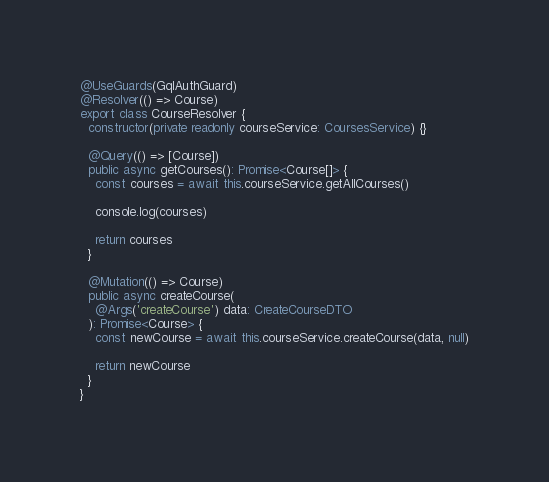Convert code to text. <code><loc_0><loc_0><loc_500><loc_500><_TypeScript_>@UseGuards(GqlAuthGuard)
@Resolver(() => Course)
export class CourseResolver {
  constructor(private readonly courseService: CoursesService) {}

  @Query(() => [Course])
  public async getCourses(): Promise<Course[]> {
    const courses = await this.courseService.getAllCourses()

    console.log(courses)

    return courses
  }

  @Mutation(() => Course)
  public async createCourse(
    @Args('createCourse') data: CreateCourseDTO
  ): Promise<Course> {
    const newCourse = await this.courseService.createCourse(data, null)

    return newCourse
  }
}
</code> 